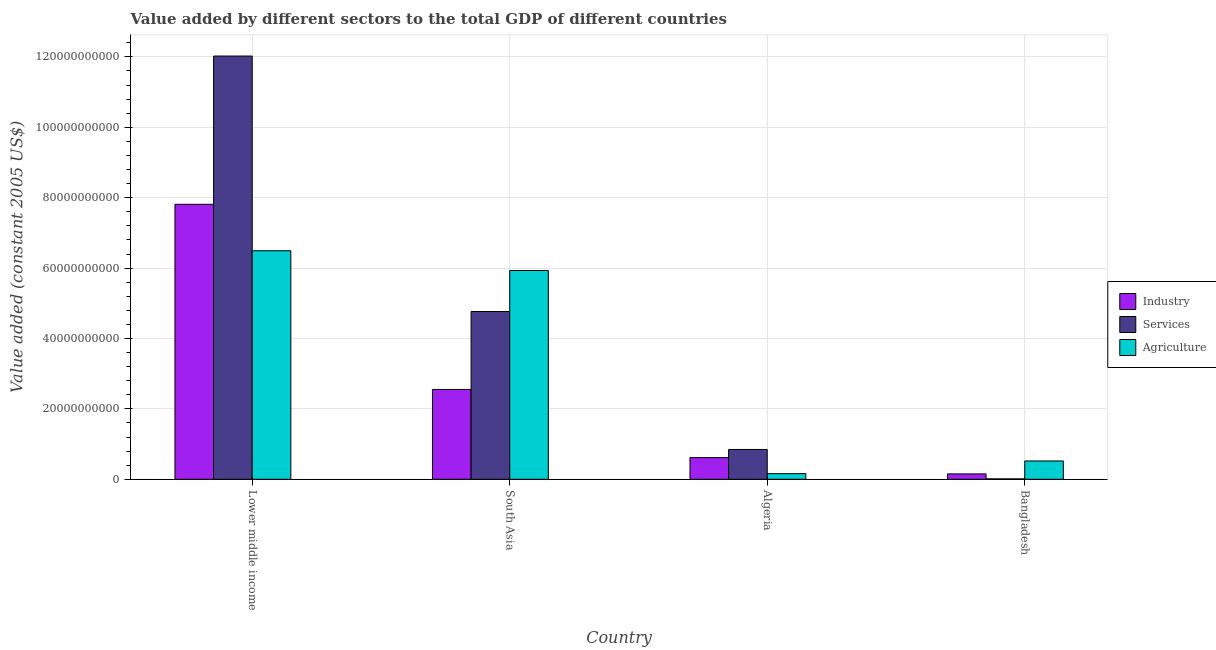Are the number of bars per tick equal to the number of legend labels?
Make the answer very short. Yes. How many bars are there on the 4th tick from the left?
Ensure brevity in your answer.  3. What is the label of the 4th group of bars from the left?
Make the answer very short. Bangladesh. What is the value added by services in South Asia?
Give a very brief answer. 4.77e+1. Across all countries, what is the maximum value added by services?
Make the answer very short. 1.20e+11. Across all countries, what is the minimum value added by agricultural sector?
Provide a short and direct response. 1.61e+09. In which country was the value added by industrial sector maximum?
Offer a terse response. Lower middle income. What is the total value added by industrial sector in the graph?
Offer a terse response. 1.11e+11. What is the difference between the value added by services in Lower middle income and that in South Asia?
Provide a short and direct response. 7.26e+1. What is the difference between the value added by agricultural sector in Algeria and the value added by industrial sector in South Asia?
Offer a very short reply. -2.39e+1. What is the average value added by agricultural sector per country?
Keep it short and to the point. 3.28e+1. What is the difference between the value added by industrial sector and value added by services in Lower middle income?
Offer a terse response. -4.21e+1. What is the ratio of the value added by services in Lower middle income to that in South Asia?
Give a very brief answer. 2.52. Is the difference between the value added by agricultural sector in Bangladesh and Lower middle income greater than the difference between the value added by services in Bangladesh and Lower middle income?
Ensure brevity in your answer.  Yes. What is the difference between the highest and the second highest value added by services?
Provide a short and direct response. 7.26e+1. What is the difference between the highest and the lowest value added by agricultural sector?
Provide a short and direct response. 6.33e+1. What does the 3rd bar from the left in Algeria represents?
Offer a very short reply. Agriculture. What does the 2nd bar from the right in Bangladesh represents?
Offer a very short reply. Services. Is it the case that in every country, the sum of the value added by industrial sector and value added by services is greater than the value added by agricultural sector?
Provide a short and direct response. No. How many countries are there in the graph?
Your answer should be compact. 4. Are the values on the major ticks of Y-axis written in scientific E-notation?
Your answer should be very brief. No. Does the graph contain any zero values?
Your response must be concise. No. Where does the legend appear in the graph?
Ensure brevity in your answer.  Center right. How many legend labels are there?
Make the answer very short. 3. What is the title of the graph?
Your answer should be very brief. Value added by different sectors to the total GDP of different countries. Does "Ages 60+" appear as one of the legend labels in the graph?
Ensure brevity in your answer.  No. What is the label or title of the X-axis?
Offer a terse response. Country. What is the label or title of the Y-axis?
Ensure brevity in your answer.  Value added (constant 2005 US$). What is the Value added (constant 2005 US$) in Industry in Lower middle income?
Give a very brief answer. 7.81e+1. What is the Value added (constant 2005 US$) in Services in Lower middle income?
Your response must be concise. 1.20e+11. What is the Value added (constant 2005 US$) in Agriculture in Lower middle income?
Provide a succinct answer. 6.49e+1. What is the Value added (constant 2005 US$) in Industry in South Asia?
Keep it short and to the point. 2.55e+1. What is the Value added (constant 2005 US$) in Services in South Asia?
Give a very brief answer. 4.77e+1. What is the Value added (constant 2005 US$) in Agriculture in South Asia?
Keep it short and to the point. 5.93e+1. What is the Value added (constant 2005 US$) in Industry in Algeria?
Provide a short and direct response. 6.17e+09. What is the Value added (constant 2005 US$) of Services in Algeria?
Your answer should be very brief. 8.47e+09. What is the Value added (constant 2005 US$) of Agriculture in Algeria?
Ensure brevity in your answer.  1.61e+09. What is the Value added (constant 2005 US$) of Industry in Bangladesh?
Your answer should be compact. 1.53e+09. What is the Value added (constant 2005 US$) of Services in Bangladesh?
Provide a short and direct response. 1.22e+08. What is the Value added (constant 2005 US$) in Agriculture in Bangladesh?
Ensure brevity in your answer.  5.21e+09. Across all countries, what is the maximum Value added (constant 2005 US$) of Industry?
Provide a succinct answer. 7.81e+1. Across all countries, what is the maximum Value added (constant 2005 US$) of Services?
Offer a very short reply. 1.20e+11. Across all countries, what is the maximum Value added (constant 2005 US$) in Agriculture?
Keep it short and to the point. 6.49e+1. Across all countries, what is the minimum Value added (constant 2005 US$) in Industry?
Offer a terse response. 1.53e+09. Across all countries, what is the minimum Value added (constant 2005 US$) of Services?
Provide a short and direct response. 1.22e+08. Across all countries, what is the minimum Value added (constant 2005 US$) in Agriculture?
Keep it short and to the point. 1.61e+09. What is the total Value added (constant 2005 US$) of Industry in the graph?
Your response must be concise. 1.11e+11. What is the total Value added (constant 2005 US$) of Services in the graph?
Give a very brief answer. 1.77e+11. What is the total Value added (constant 2005 US$) in Agriculture in the graph?
Give a very brief answer. 1.31e+11. What is the difference between the Value added (constant 2005 US$) of Industry in Lower middle income and that in South Asia?
Keep it short and to the point. 5.26e+1. What is the difference between the Value added (constant 2005 US$) of Services in Lower middle income and that in South Asia?
Make the answer very short. 7.26e+1. What is the difference between the Value added (constant 2005 US$) of Agriculture in Lower middle income and that in South Asia?
Your answer should be compact. 5.62e+09. What is the difference between the Value added (constant 2005 US$) in Industry in Lower middle income and that in Algeria?
Your answer should be compact. 7.20e+1. What is the difference between the Value added (constant 2005 US$) in Services in Lower middle income and that in Algeria?
Provide a short and direct response. 1.12e+11. What is the difference between the Value added (constant 2005 US$) of Agriculture in Lower middle income and that in Algeria?
Offer a very short reply. 6.33e+1. What is the difference between the Value added (constant 2005 US$) in Industry in Lower middle income and that in Bangladesh?
Your answer should be very brief. 7.66e+1. What is the difference between the Value added (constant 2005 US$) of Services in Lower middle income and that in Bangladesh?
Provide a succinct answer. 1.20e+11. What is the difference between the Value added (constant 2005 US$) in Agriculture in Lower middle income and that in Bangladesh?
Ensure brevity in your answer.  5.97e+1. What is the difference between the Value added (constant 2005 US$) of Industry in South Asia and that in Algeria?
Make the answer very short. 1.94e+1. What is the difference between the Value added (constant 2005 US$) in Services in South Asia and that in Algeria?
Offer a terse response. 3.92e+1. What is the difference between the Value added (constant 2005 US$) of Agriculture in South Asia and that in Algeria?
Offer a terse response. 5.77e+1. What is the difference between the Value added (constant 2005 US$) in Industry in South Asia and that in Bangladesh?
Provide a short and direct response. 2.40e+1. What is the difference between the Value added (constant 2005 US$) of Services in South Asia and that in Bangladesh?
Provide a succinct answer. 4.75e+1. What is the difference between the Value added (constant 2005 US$) of Agriculture in South Asia and that in Bangladesh?
Ensure brevity in your answer.  5.41e+1. What is the difference between the Value added (constant 2005 US$) in Industry in Algeria and that in Bangladesh?
Offer a terse response. 4.64e+09. What is the difference between the Value added (constant 2005 US$) in Services in Algeria and that in Bangladesh?
Your response must be concise. 8.35e+09. What is the difference between the Value added (constant 2005 US$) in Agriculture in Algeria and that in Bangladesh?
Provide a short and direct response. -3.60e+09. What is the difference between the Value added (constant 2005 US$) in Industry in Lower middle income and the Value added (constant 2005 US$) in Services in South Asia?
Your response must be concise. 3.05e+1. What is the difference between the Value added (constant 2005 US$) of Industry in Lower middle income and the Value added (constant 2005 US$) of Agriculture in South Asia?
Your response must be concise. 1.88e+1. What is the difference between the Value added (constant 2005 US$) of Services in Lower middle income and the Value added (constant 2005 US$) of Agriculture in South Asia?
Offer a very short reply. 6.09e+1. What is the difference between the Value added (constant 2005 US$) of Industry in Lower middle income and the Value added (constant 2005 US$) of Services in Algeria?
Ensure brevity in your answer.  6.97e+1. What is the difference between the Value added (constant 2005 US$) in Industry in Lower middle income and the Value added (constant 2005 US$) in Agriculture in Algeria?
Provide a short and direct response. 7.65e+1. What is the difference between the Value added (constant 2005 US$) in Services in Lower middle income and the Value added (constant 2005 US$) in Agriculture in Algeria?
Ensure brevity in your answer.  1.19e+11. What is the difference between the Value added (constant 2005 US$) in Industry in Lower middle income and the Value added (constant 2005 US$) in Services in Bangladesh?
Keep it short and to the point. 7.80e+1. What is the difference between the Value added (constant 2005 US$) of Industry in Lower middle income and the Value added (constant 2005 US$) of Agriculture in Bangladesh?
Give a very brief answer. 7.29e+1. What is the difference between the Value added (constant 2005 US$) in Services in Lower middle income and the Value added (constant 2005 US$) in Agriculture in Bangladesh?
Give a very brief answer. 1.15e+11. What is the difference between the Value added (constant 2005 US$) in Industry in South Asia and the Value added (constant 2005 US$) in Services in Algeria?
Keep it short and to the point. 1.71e+1. What is the difference between the Value added (constant 2005 US$) in Industry in South Asia and the Value added (constant 2005 US$) in Agriculture in Algeria?
Make the answer very short. 2.39e+1. What is the difference between the Value added (constant 2005 US$) of Services in South Asia and the Value added (constant 2005 US$) of Agriculture in Algeria?
Keep it short and to the point. 4.61e+1. What is the difference between the Value added (constant 2005 US$) of Industry in South Asia and the Value added (constant 2005 US$) of Services in Bangladesh?
Give a very brief answer. 2.54e+1. What is the difference between the Value added (constant 2005 US$) of Industry in South Asia and the Value added (constant 2005 US$) of Agriculture in Bangladesh?
Keep it short and to the point. 2.03e+1. What is the difference between the Value added (constant 2005 US$) in Services in South Asia and the Value added (constant 2005 US$) in Agriculture in Bangladesh?
Your response must be concise. 4.25e+1. What is the difference between the Value added (constant 2005 US$) in Industry in Algeria and the Value added (constant 2005 US$) in Services in Bangladesh?
Make the answer very short. 6.05e+09. What is the difference between the Value added (constant 2005 US$) in Industry in Algeria and the Value added (constant 2005 US$) in Agriculture in Bangladesh?
Offer a terse response. 9.62e+08. What is the difference between the Value added (constant 2005 US$) in Services in Algeria and the Value added (constant 2005 US$) in Agriculture in Bangladesh?
Your response must be concise. 3.26e+09. What is the average Value added (constant 2005 US$) of Industry per country?
Ensure brevity in your answer.  2.78e+1. What is the average Value added (constant 2005 US$) in Services per country?
Your answer should be compact. 4.41e+1. What is the average Value added (constant 2005 US$) in Agriculture per country?
Offer a terse response. 3.28e+1. What is the difference between the Value added (constant 2005 US$) in Industry and Value added (constant 2005 US$) in Services in Lower middle income?
Your response must be concise. -4.21e+1. What is the difference between the Value added (constant 2005 US$) of Industry and Value added (constant 2005 US$) of Agriculture in Lower middle income?
Offer a terse response. 1.32e+1. What is the difference between the Value added (constant 2005 US$) of Services and Value added (constant 2005 US$) of Agriculture in Lower middle income?
Ensure brevity in your answer.  5.53e+1. What is the difference between the Value added (constant 2005 US$) in Industry and Value added (constant 2005 US$) in Services in South Asia?
Make the answer very short. -2.21e+1. What is the difference between the Value added (constant 2005 US$) of Industry and Value added (constant 2005 US$) of Agriculture in South Asia?
Your answer should be compact. -3.38e+1. What is the difference between the Value added (constant 2005 US$) in Services and Value added (constant 2005 US$) in Agriculture in South Asia?
Keep it short and to the point. -1.17e+1. What is the difference between the Value added (constant 2005 US$) in Industry and Value added (constant 2005 US$) in Services in Algeria?
Your answer should be compact. -2.30e+09. What is the difference between the Value added (constant 2005 US$) of Industry and Value added (constant 2005 US$) of Agriculture in Algeria?
Provide a short and direct response. 4.56e+09. What is the difference between the Value added (constant 2005 US$) in Services and Value added (constant 2005 US$) in Agriculture in Algeria?
Give a very brief answer. 6.86e+09. What is the difference between the Value added (constant 2005 US$) of Industry and Value added (constant 2005 US$) of Services in Bangladesh?
Your response must be concise. 1.41e+09. What is the difference between the Value added (constant 2005 US$) in Industry and Value added (constant 2005 US$) in Agriculture in Bangladesh?
Your answer should be compact. -3.68e+09. What is the difference between the Value added (constant 2005 US$) in Services and Value added (constant 2005 US$) in Agriculture in Bangladesh?
Give a very brief answer. -5.08e+09. What is the ratio of the Value added (constant 2005 US$) in Industry in Lower middle income to that in South Asia?
Give a very brief answer. 3.06. What is the ratio of the Value added (constant 2005 US$) in Services in Lower middle income to that in South Asia?
Keep it short and to the point. 2.52. What is the ratio of the Value added (constant 2005 US$) in Agriculture in Lower middle income to that in South Asia?
Your response must be concise. 1.09. What is the ratio of the Value added (constant 2005 US$) in Industry in Lower middle income to that in Algeria?
Your answer should be very brief. 12.67. What is the ratio of the Value added (constant 2005 US$) of Services in Lower middle income to that in Algeria?
Make the answer very short. 14.2. What is the ratio of the Value added (constant 2005 US$) in Agriculture in Lower middle income to that in Algeria?
Make the answer very short. 40.37. What is the ratio of the Value added (constant 2005 US$) in Industry in Lower middle income to that in Bangladesh?
Provide a succinct answer. 51.04. What is the ratio of the Value added (constant 2005 US$) in Services in Lower middle income to that in Bangladesh?
Offer a very short reply. 987.49. What is the ratio of the Value added (constant 2005 US$) in Agriculture in Lower middle income to that in Bangladesh?
Your answer should be compact. 12.47. What is the ratio of the Value added (constant 2005 US$) in Industry in South Asia to that in Algeria?
Ensure brevity in your answer.  4.14. What is the ratio of the Value added (constant 2005 US$) of Services in South Asia to that in Algeria?
Give a very brief answer. 5.63. What is the ratio of the Value added (constant 2005 US$) in Agriculture in South Asia to that in Algeria?
Provide a succinct answer. 36.88. What is the ratio of the Value added (constant 2005 US$) of Industry in South Asia to that in Bangladesh?
Provide a succinct answer. 16.68. What is the ratio of the Value added (constant 2005 US$) in Services in South Asia to that in Bangladesh?
Provide a short and direct response. 391.45. What is the ratio of the Value added (constant 2005 US$) of Agriculture in South Asia to that in Bangladesh?
Your response must be concise. 11.39. What is the ratio of the Value added (constant 2005 US$) of Industry in Algeria to that in Bangladesh?
Your answer should be compact. 4.03. What is the ratio of the Value added (constant 2005 US$) in Services in Algeria to that in Bangladesh?
Your answer should be compact. 69.55. What is the ratio of the Value added (constant 2005 US$) of Agriculture in Algeria to that in Bangladesh?
Give a very brief answer. 0.31. What is the difference between the highest and the second highest Value added (constant 2005 US$) in Industry?
Provide a succinct answer. 5.26e+1. What is the difference between the highest and the second highest Value added (constant 2005 US$) of Services?
Offer a terse response. 7.26e+1. What is the difference between the highest and the second highest Value added (constant 2005 US$) in Agriculture?
Your answer should be compact. 5.62e+09. What is the difference between the highest and the lowest Value added (constant 2005 US$) of Industry?
Provide a short and direct response. 7.66e+1. What is the difference between the highest and the lowest Value added (constant 2005 US$) in Services?
Provide a succinct answer. 1.20e+11. What is the difference between the highest and the lowest Value added (constant 2005 US$) of Agriculture?
Provide a succinct answer. 6.33e+1. 